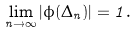<formula> <loc_0><loc_0><loc_500><loc_500>\lim _ { n \to \infty } | \phi ( \Delta _ { n } ) | = 1 .</formula> 